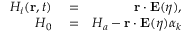Convert formula to latex. <formula><loc_0><loc_0><loc_500><loc_500>\begin{array} { r l r } { H _ { i } ( r , t ) } & = } & { r \cdot E ( \eta ) , } \\ { H _ { 0 } } & = } & { H _ { a } - r \cdot E ( \eta ) \alpha _ { k } } \end{array}</formula> 